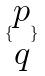<formula> <loc_0><loc_0><loc_500><loc_500>\{ \begin{matrix} p \\ q \end{matrix} \}</formula> 